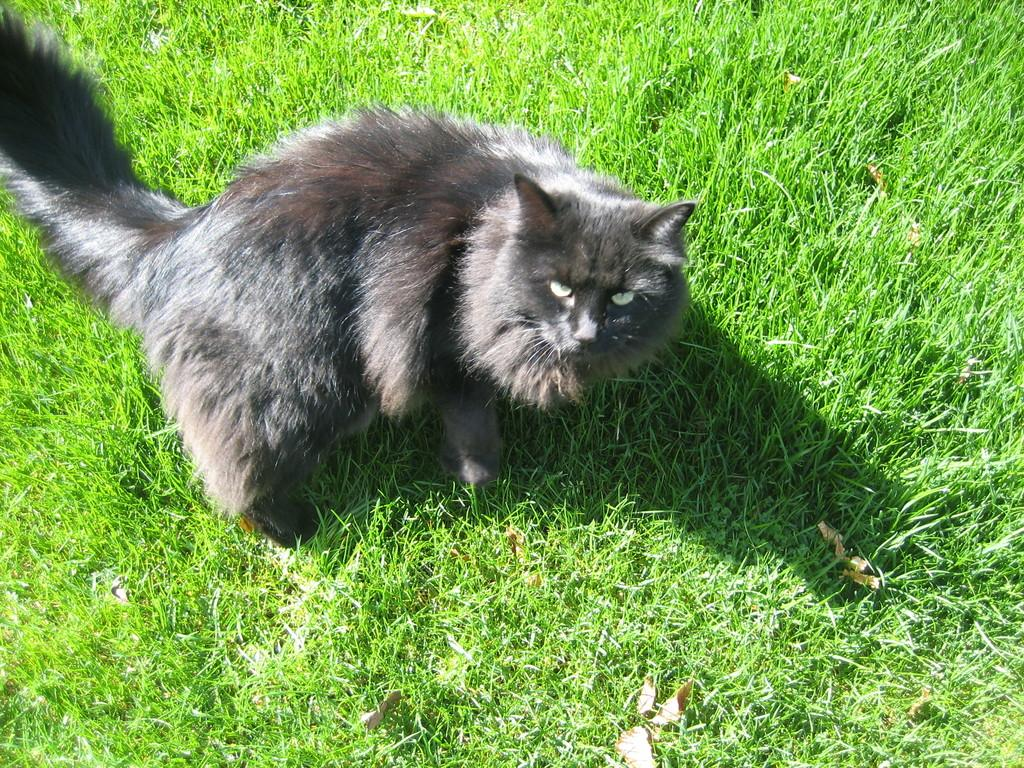What is the main subject in the center of the image? There is a cat in the center of the image. What can be seen at the bottom of the image? The ground is visible at the bottom of the image. What type of vegetation covers the ground in the image? The ground is covered with grass. What type of shirt is the laborer wearing in the image? There is no laborer or shirt present in the image; it features a cat and grass-covered ground. 